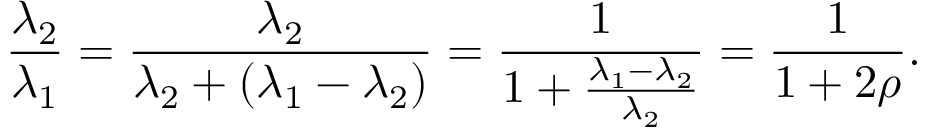Convert formula to latex. <formula><loc_0><loc_0><loc_500><loc_500>{ \frac { \lambda _ { 2 } } { \lambda _ { 1 } } } = { \frac { \lambda _ { 2 } } { \lambda _ { 2 } + ( \lambda _ { 1 } - \lambda _ { 2 } ) } } = { \frac { 1 } { 1 + { \frac { \lambda _ { 1 } - \lambda _ { 2 } } { \lambda _ { 2 } } } } } = { \frac { 1 } { 1 + 2 \rho } } .</formula> 